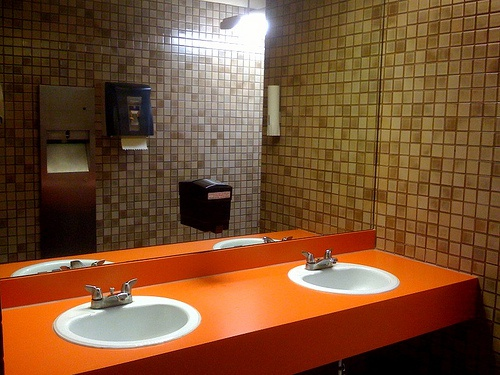Describe the objects in this image and their specific colors. I can see sink in black, darkgray, white, and lightgray tones and sink in black, lightgray, and darkgray tones in this image. 